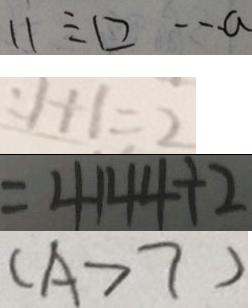Convert formula to latex. <formula><loc_0><loc_0><loc_500><loc_500>1 1 \div \square \cdots a 
 : 1 + 1 = 2 
 = 4 1 4 4 \div 2 
 ( A > 7 )</formula> 